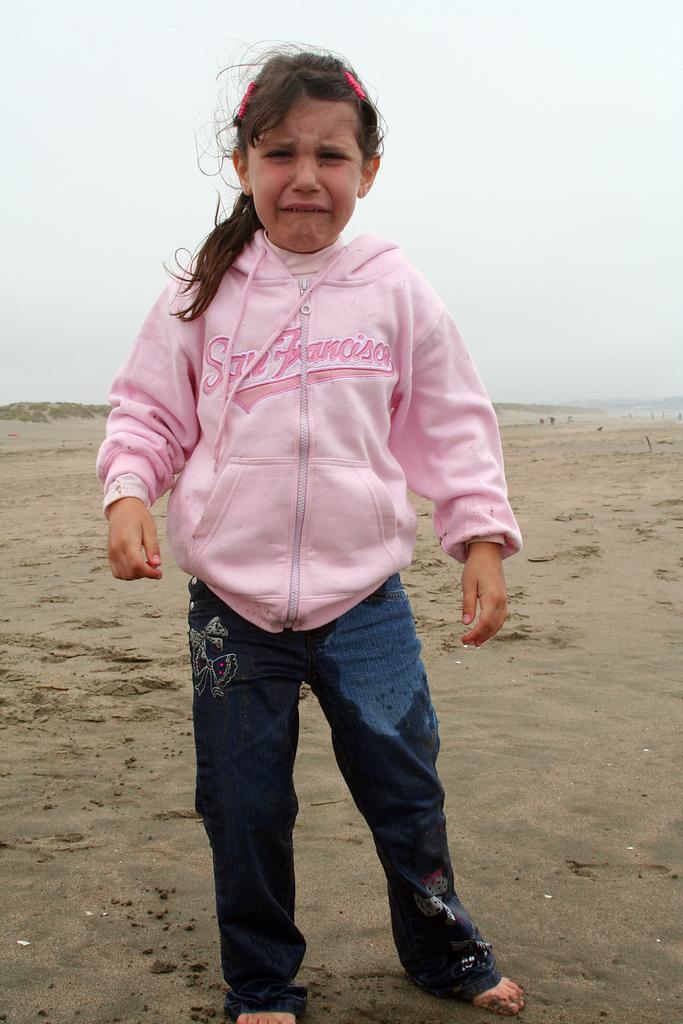In one or two sentences, can you explain what this image depicts? In this image there is a girl who is crying. There is sand. The sky is clear. 